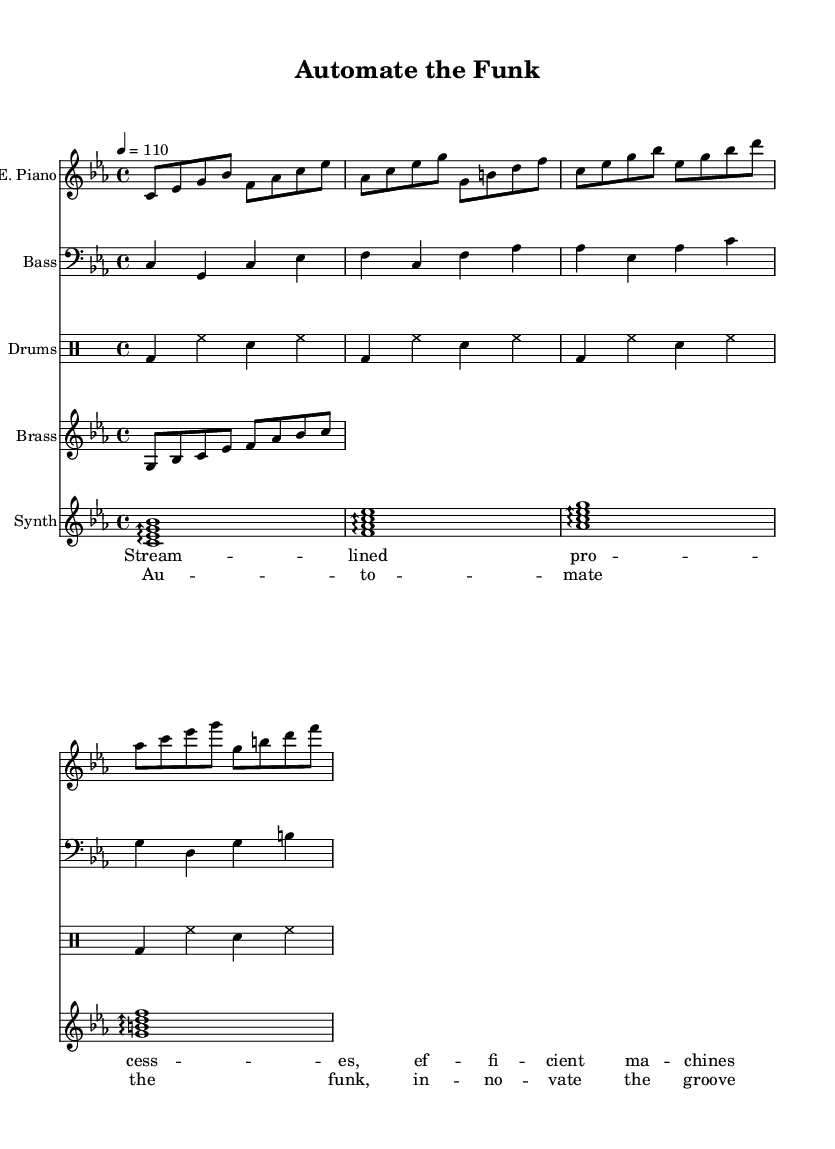What is the key signature of this music? The key signature is C minor, which has three flats (B♭, E♭, and A♭). This can be identified by the 'C' in the global section and the minor designation.
Answer: C minor What is the time signature of this music? The time signature is 4/4, which indicates that there are four beats in each measure and the quarter note receives one beat. This is explicitly stated in the global section of the score.
Answer: 4/4 What is the tempo marking of the piece? The tempo marking is 110 beats per minute, indicated in the global section as "4 = 110," showing the speed at which the piece should be played.
Answer: 110 How many different instrumental parts are included in this score? The score contains five different instrumental parts: Electric Piano, Bass, Drums, Brass, and Synth. This can be counted by looking at the score sections for each individual staff.
Answer: Five What is the first lyric line of the verse? The first lyric line of the verse is "Stream -- lined pro -- cess -- es, ef -- fi -- cient ma -- chines." This text corresponds to the verseWords section and can be found directly beneath the electric piano notes.
Answer: Stream -- lined pro -- cess -- es, ef -- fi -- cient ma -- chines Which instrument plays the chorus melody? The chorus melody is primarily played by the Electric Piano, as seen in the electricPiano part where the corresponding notes for the chorus lyrics are located.
Answer: Electric Piano What genre of music does this piece belong to? The piece belongs to the Funky Soul genre, as indicated by the title "Automate the Funk" and its thematic focus on technological innovation, which is characteristic of the Funky Soul style.
Answer: Funky Soul 